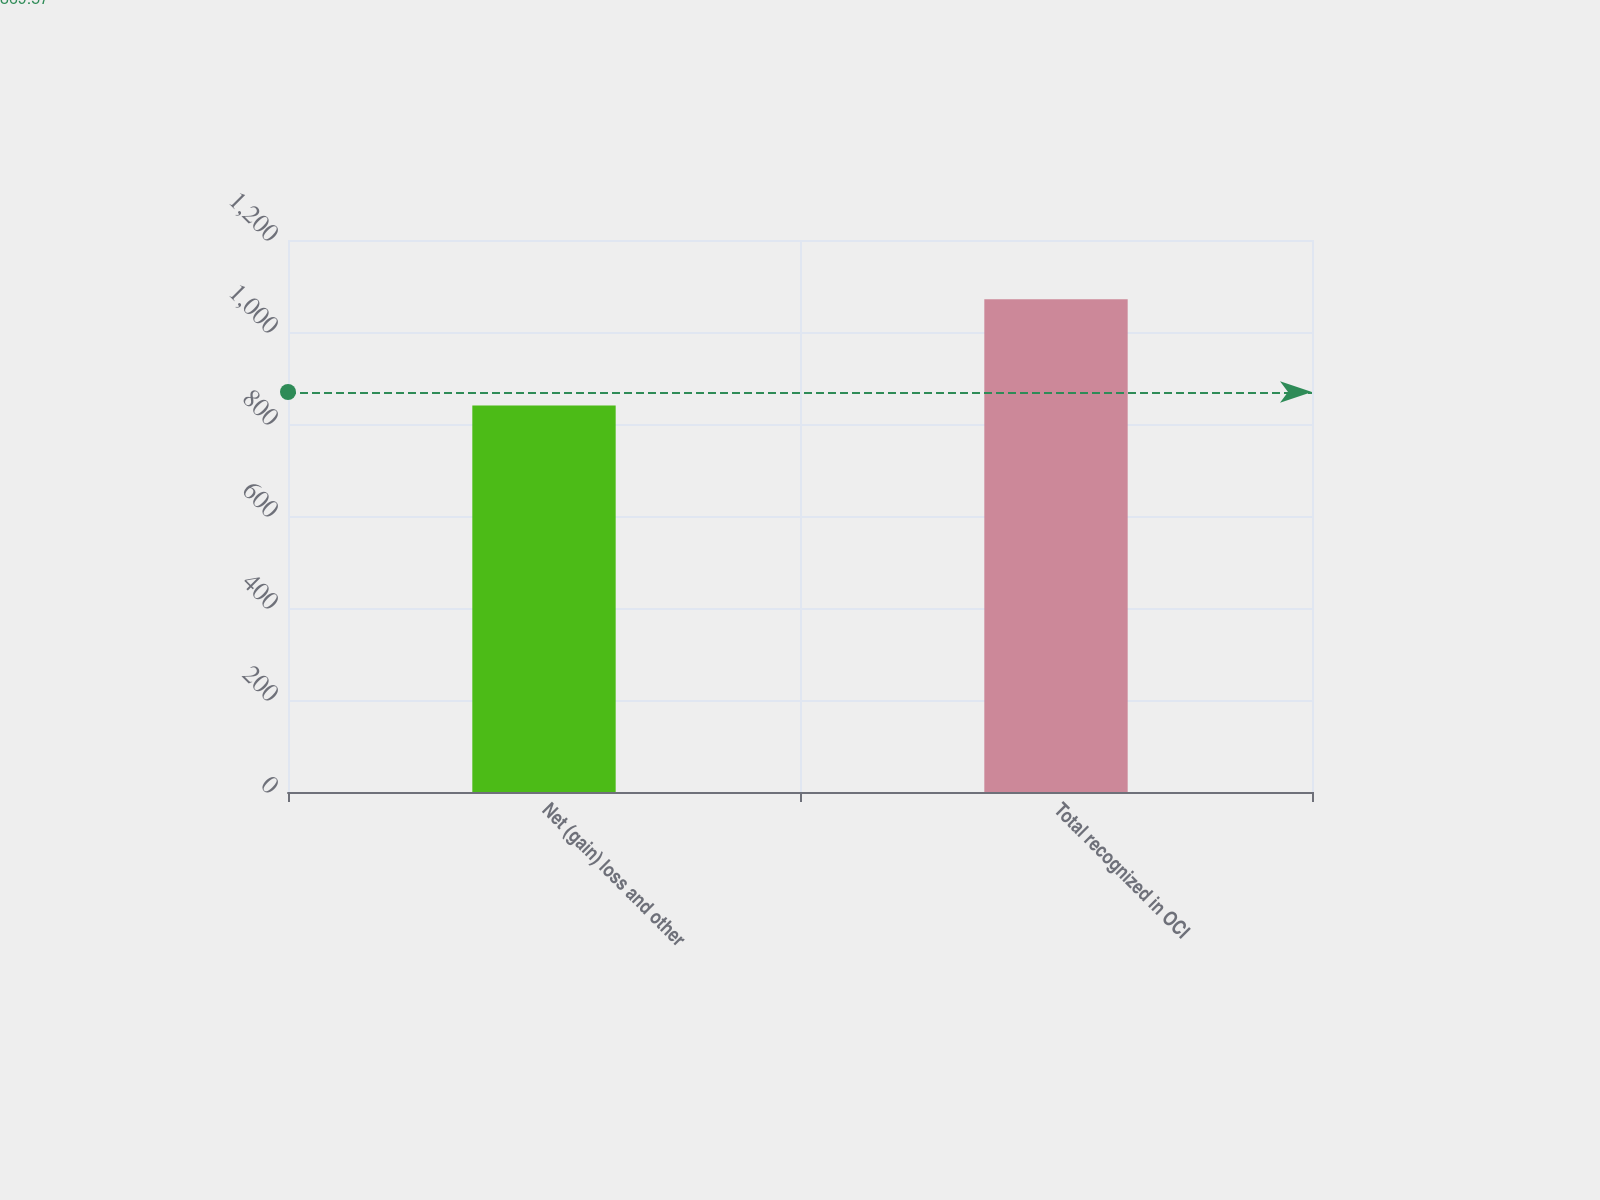<chart> <loc_0><loc_0><loc_500><loc_500><bar_chart><fcel>Net (gain) loss and other<fcel>Total recognized in OCI<nl><fcel>840<fcel>1071<nl></chart> 